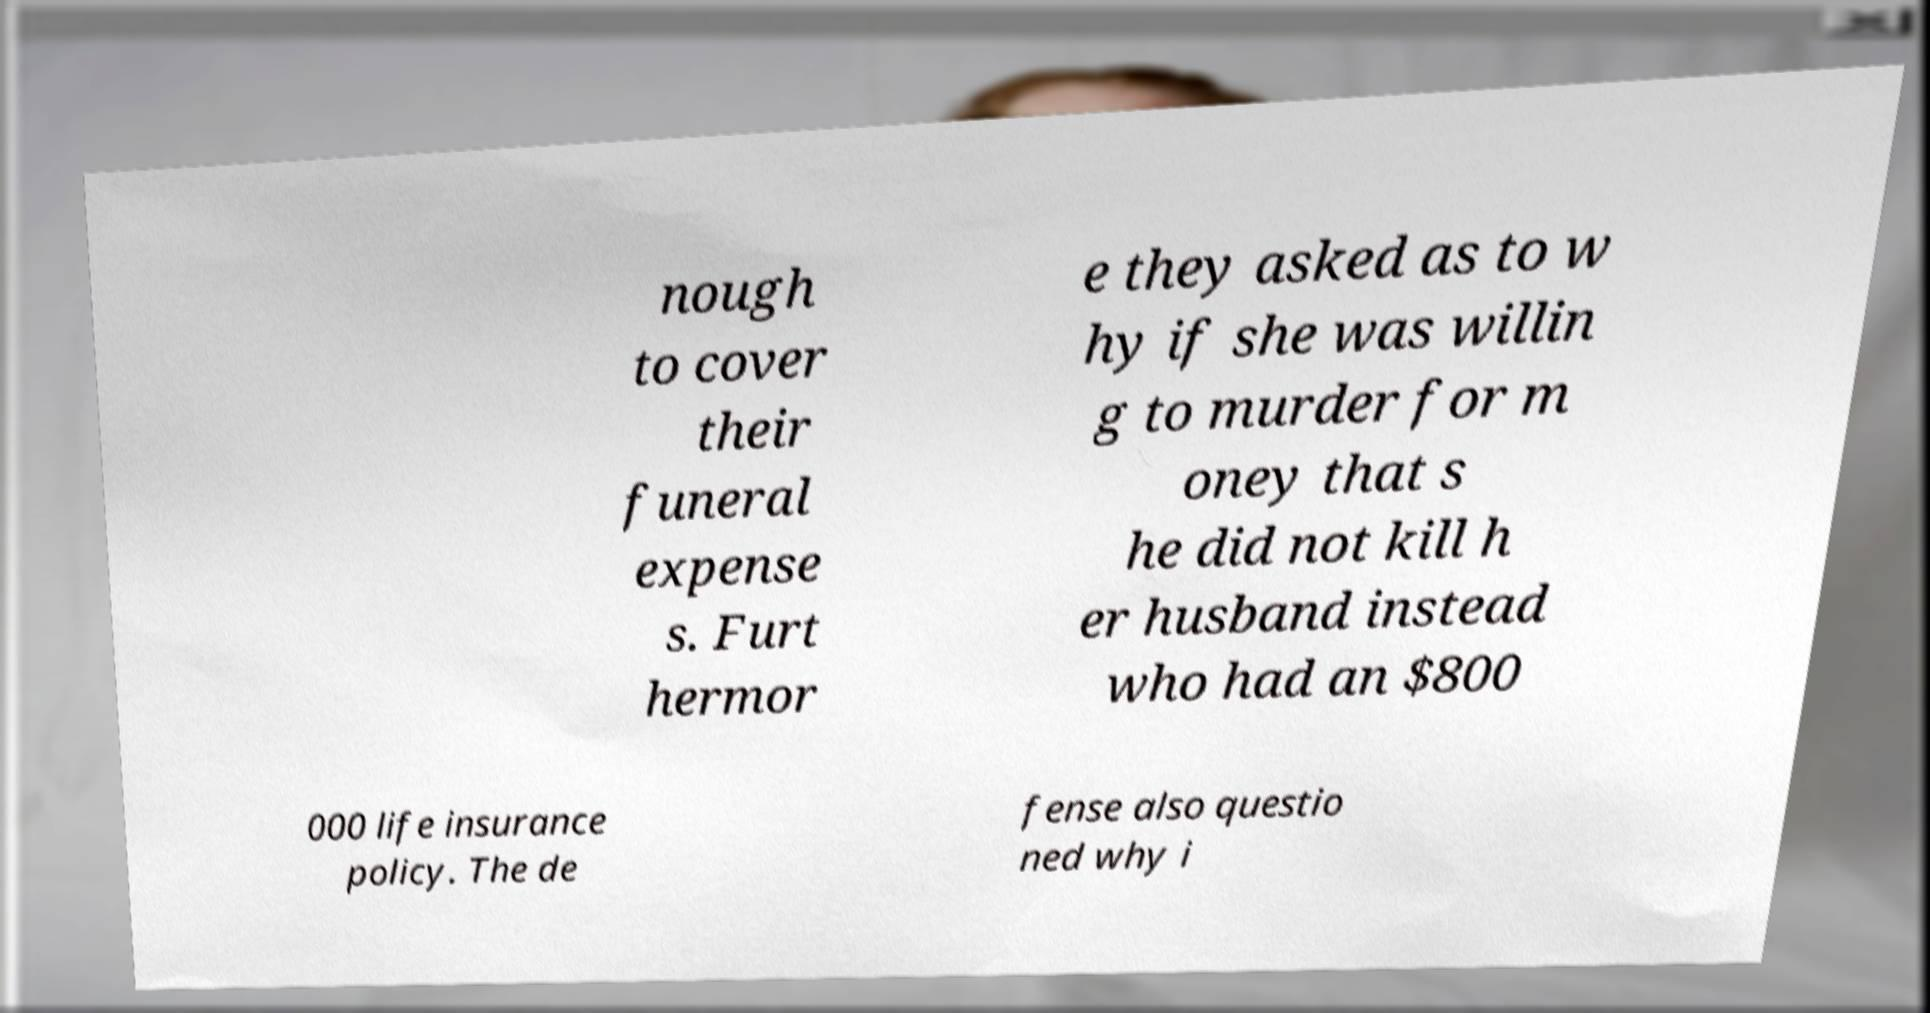For documentation purposes, I need the text within this image transcribed. Could you provide that? nough to cover their funeral expense s. Furt hermor e they asked as to w hy if she was willin g to murder for m oney that s he did not kill h er husband instead who had an $800 000 life insurance policy. The de fense also questio ned why i 